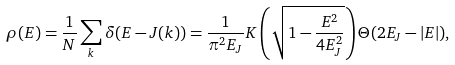<formula> <loc_0><loc_0><loc_500><loc_500>\rho ( E ) = \frac { 1 } { N } \sum _ { k } { \delta ( E - J ( { k } ) ) } = \frac { 1 } { \pi ^ { 2 } E _ { J } } { K } \left ( \sqrt { 1 - \frac { E ^ { 2 } } { 4 E _ { J } ^ { 2 } } } \right ) \Theta ( 2 E _ { J } - | E | ) ,</formula> 